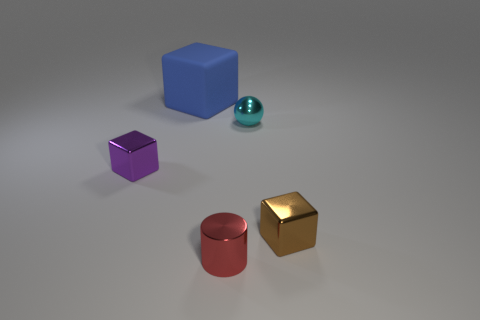What is the material of the other large object that is the same shape as the purple metallic object?
Provide a succinct answer. Rubber. The cylinder is what color?
Provide a short and direct response. Red. How many rubber things are tiny brown blocks or tiny spheres?
Offer a terse response. 0. There is a small thing behind the small metal block left of the brown shiny thing; are there any tiny shiny objects that are on the right side of it?
Provide a short and direct response. Yes. There is a red thing; are there any cyan metallic balls to the right of it?
Make the answer very short. Yes. There is a cube that is to the right of the small red cylinder; are there any large matte blocks in front of it?
Provide a short and direct response. No. Do the metallic cube behind the brown shiny thing and the block that is behind the tiny cyan thing have the same size?
Offer a terse response. No. What number of large objects are red rubber balls or matte things?
Your answer should be compact. 1. What is the material of the object that is in front of the metal cube that is to the right of the purple shiny cube?
Provide a succinct answer. Metal. Are there any red cylinders made of the same material as the ball?
Your answer should be very brief. Yes. 